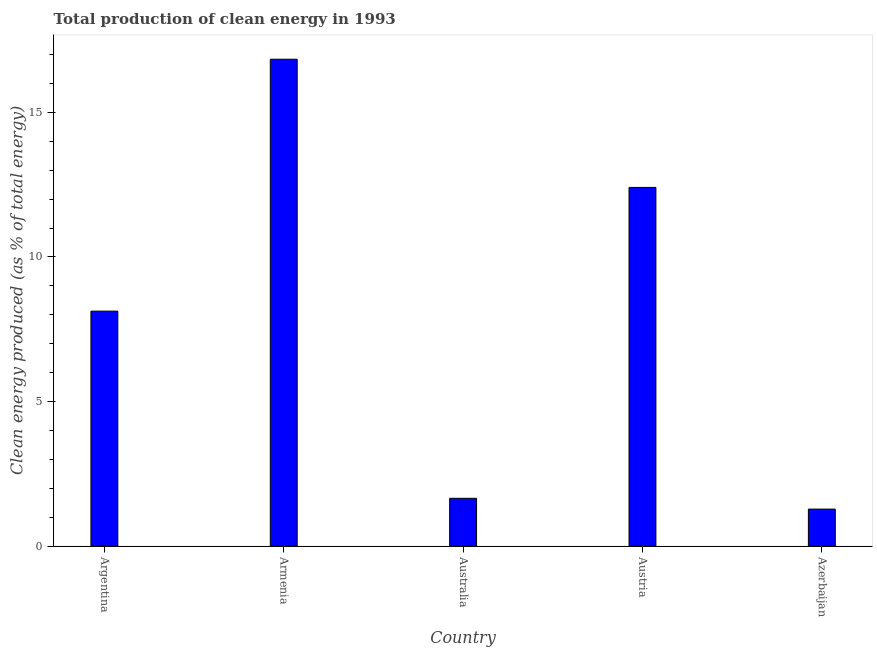Does the graph contain any zero values?
Keep it short and to the point. No. What is the title of the graph?
Your answer should be very brief. Total production of clean energy in 1993. What is the label or title of the X-axis?
Keep it short and to the point. Country. What is the label or title of the Y-axis?
Give a very brief answer. Clean energy produced (as % of total energy). What is the production of clean energy in Austria?
Provide a short and direct response. 12.4. Across all countries, what is the maximum production of clean energy?
Offer a terse response. 16.84. Across all countries, what is the minimum production of clean energy?
Your answer should be compact. 1.28. In which country was the production of clean energy maximum?
Your answer should be very brief. Armenia. In which country was the production of clean energy minimum?
Your answer should be very brief. Azerbaijan. What is the sum of the production of clean energy?
Offer a terse response. 40.3. What is the difference between the production of clean energy in Argentina and Armenia?
Your answer should be very brief. -8.71. What is the average production of clean energy per country?
Offer a terse response. 8.06. What is the median production of clean energy?
Your answer should be compact. 8.13. What is the ratio of the production of clean energy in Armenia to that in Azerbaijan?
Your answer should be compact. 13.16. Is the production of clean energy in Argentina less than that in Armenia?
Provide a succinct answer. Yes. Is the difference between the production of clean energy in Australia and Azerbaijan greater than the difference between any two countries?
Offer a very short reply. No. What is the difference between the highest and the second highest production of clean energy?
Your answer should be very brief. 4.43. What is the difference between the highest and the lowest production of clean energy?
Your answer should be very brief. 15.56. In how many countries, is the production of clean energy greater than the average production of clean energy taken over all countries?
Your answer should be compact. 3. How many bars are there?
Make the answer very short. 5. Are all the bars in the graph horizontal?
Ensure brevity in your answer.  No. What is the difference between two consecutive major ticks on the Y-axis?
Your answer should be very brief. 5. What is the Clean energy produced (as % of total energy) of Argentina?
Provide a short and direct response. 8.13. What is the Clean energy produced (as % of total energy) in Armenia?
Provide a succinct answer. 16.84. What is the Clean energy produced (as % of total energy) in Australia?
Provide a succinct answer. 1.65. What is the Clean energy produced (as % of total energy) of Austria?
Make the answer very short. 12.4. What is the Clean energy produced (as % of total energy) of Azerbaijan?
Make the answer very short. 1.28. What is the difference between the Clean energy produced (as % of total energy) in Argentina and Armenia?
Keep it short and to the point. -8.71. What is the difference between the Clean energy produced (as % of total energy) in Argentina and Australia?
Your response must be concise. 6.47. What is the difference between the Clean energy produced (as % of total energy) in Argentina and Austria?
Your response must be concise. -4.28. What is the difference between the Clean energy produced (as % of total energy) in Argentina and Azerbaijan?
Keep it short and to the point. 6.85. What is the difference between the Clean energy produced (as % of total energy) in Armenia and Australia?
Your answer should be compact. 15.19. What is the difference between the Clean energy produced (as % of total energy) in Armenia and Austria?
Your answer should be very brief. 4.43. What is the difference between the Clean energy produced (as % of total energy) in Armenia and Azerbaijan?
Keep it short and to the point. 15.56. What is the difference between the Clean energy produced (as % of total energy) in Australia and Austria?
Keep it short and to the point. -10.75. What is the difference between the Clean energy produced (as % of total energy) in Australia and Azerbaijan?
Offer a terse response. 0.37. What is the difference between the Clean energy produced (as % of total energy) in Austria and Azerbaijan?
Your response must be concise. 11.12. What is the ratio of the Clean energy produced (as % of total energy) in Argentina to that in Armenia?
Offer a terse response. 0.48. What is the ratio of the Clean energy produced (as % of total energy) in Argentina to that in Australia?
Keep it short and to the point. 4.92. What is the ratio of the Clean energy produced (as % of total energy) in Argentina to that in Austria?
Your answer should be very brief. 0.66. What is the ratio of the Clean energy produced (as % of total energy) in Argentina to that in Azerbaijan?
Your answer should be very brief. 6.35. What is the ratio of the Clean energy produced (as % of total energy) in Armenia to that in Australia?
Your answer should be very brief. 10.19. What is the ratio of the Clean energy produced (as % of total energy) in Armenia to that in Austria?
Ensure brevity in your answer.  1.36. What is the ratio of the Clean energy produced (as % of total energy) in Armenia to that in Azerbaijan?
Provide a short and direct response. 13.16. What is the ratio of the Clean energy produced (as % of total energy) in Australia to that in Austria?
Your response must be concise. 0.13. What is the ratio of the Clean energy produced (as % of total energy) in Australia to that in Azerbaijan?
Keep it short and to the point. 1.29. What is the ratio of the Clean energy produced (as % of total energy) in Austria to that in Azerbaijan?
Your answer should be compact. 9.69. 